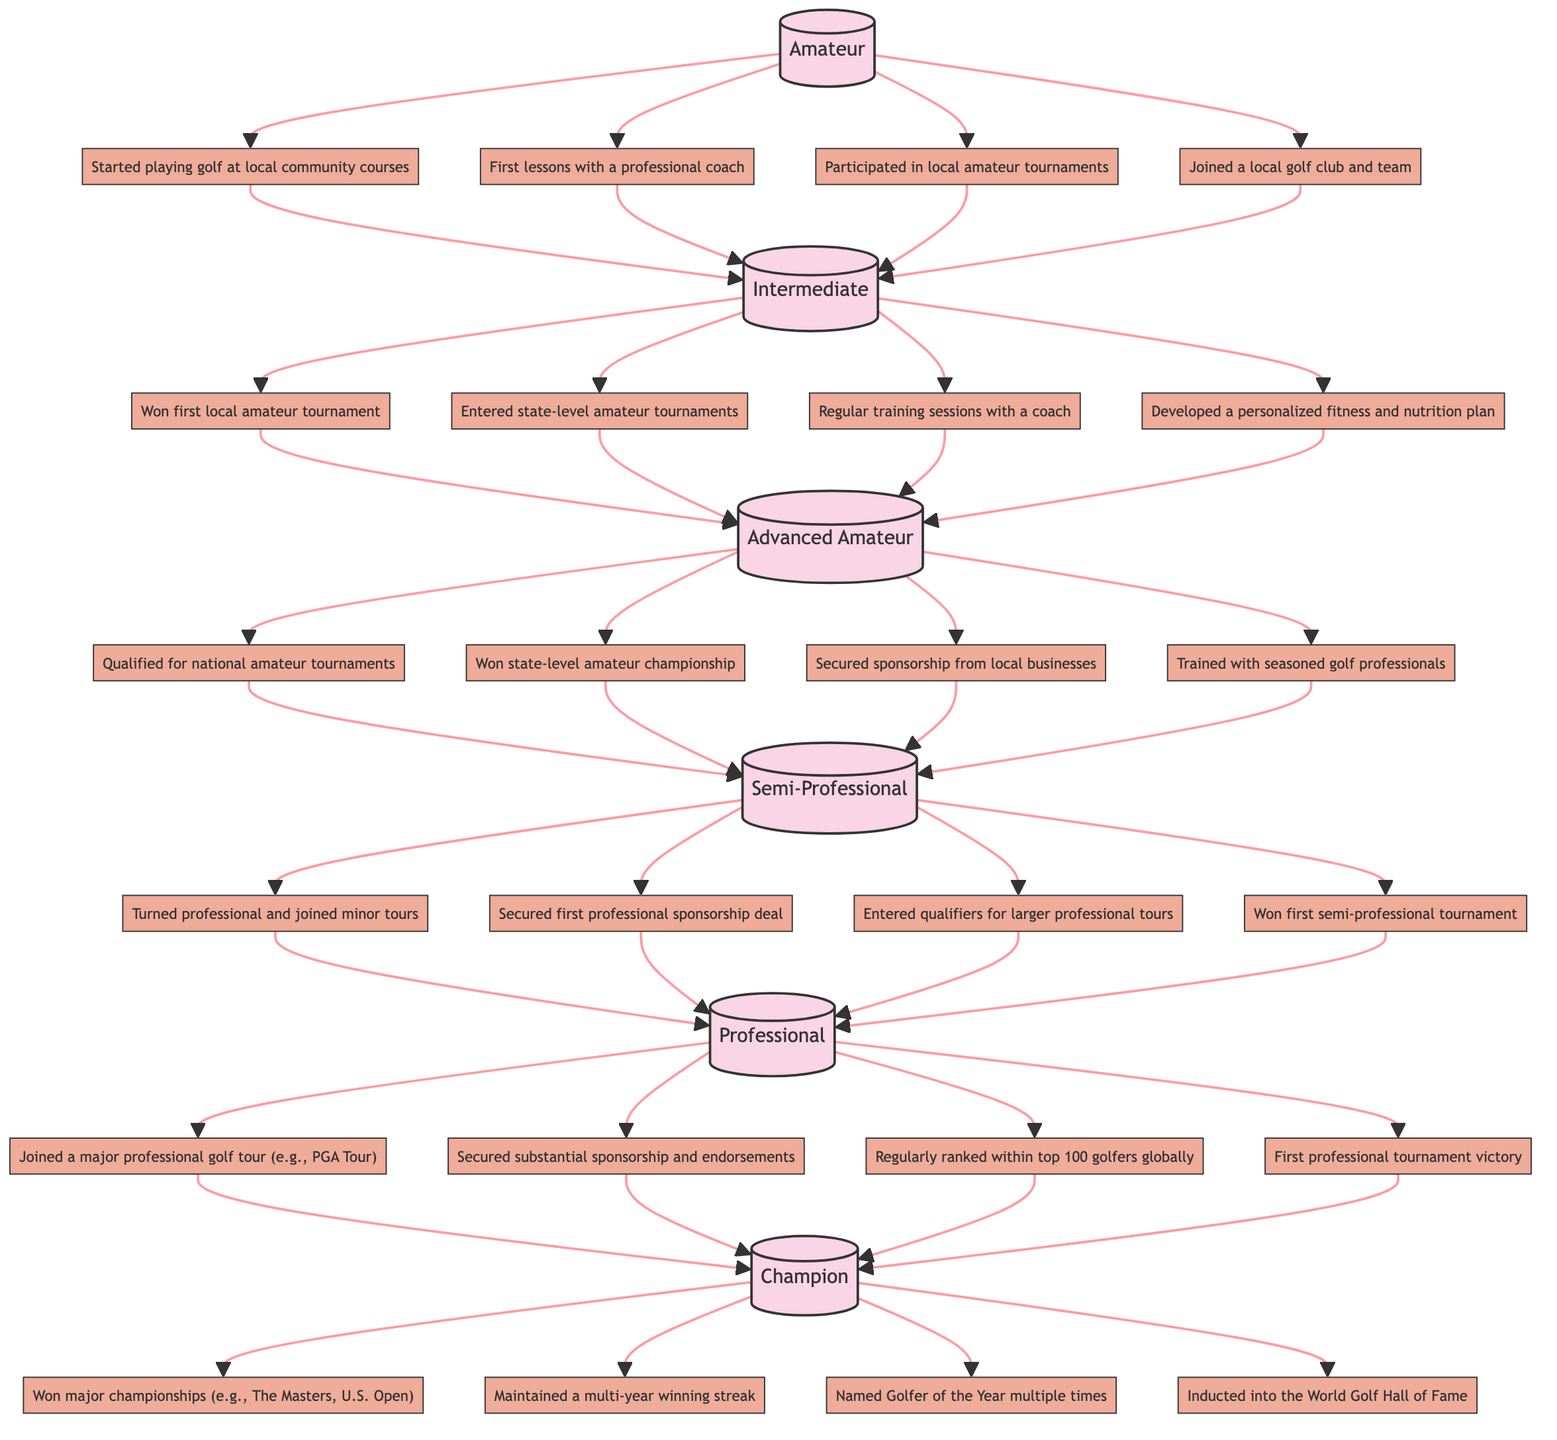What is the highest level in the golf career progression? The highest level in the diagram is labeled as "Champion," which is positioned at the top of the flowchart.
Answer: Champion How many milestones are listed under the "Semi-Professional" level? Upon reviewing the "Semi-Professional" level, there are four milestones branching from it, indicating the number of achievements at this level.
Answer: 4 What milestone comes directly after winning the first local amateur tournament? The milestone following the first local amateur tournament is "Entered state-level amateur tournaments," which is the second milestone under the "Intermediate" level.
Answer: Entered state-level amateur tournaments Which level follows after the "Advanced Amateur"? The next level after "Advanced Amateur," as per the direction of the flowchart, is "Semi-Professional," indicating the progression in the career path.
Answer: Semi-Professional What is one of the milestones under the "Champion" level? Among the several milestones under the "Champion" level, "Won major championships (e.g., The Masters, U.S. Open)" is one of the significant achievements listed.
Answer: Won major championships (e.g., The Masters, U.S. Open) What is the relationship between "Amateur" and "Intermediate"? The relationship shown in the diagram indicates that "Amateur" is a prerequisite for reaching the "Intermediate" level, connected by an upward arrow demonstrating progression from one to the next.
Answer: Progression How many levels are in the golf career progression represented in the diagram? The diagram clearly outlines a total of six levels, counting from "Amateur" to "Champion" without skipping any steps.
Answer: 6 What milestone indicates the start of professional tournaments? The milestone that marks the beginning of participation in professional tournaments is "Turned professional and joined minor tours," which is the first milestone under the "Semi-Professional" level.
Answer: Turned professional and joined minor tours Which milestone showcases a significant recognition for a golfer at the "Champion" level? The milestone that showcases significant recognition at the "Champion" level is "Inducted into the World Golf Hall of Fame," representing a prestigious achievement in a golfer's career.
Answer: Inducted into the World Golf Hall of Fame 